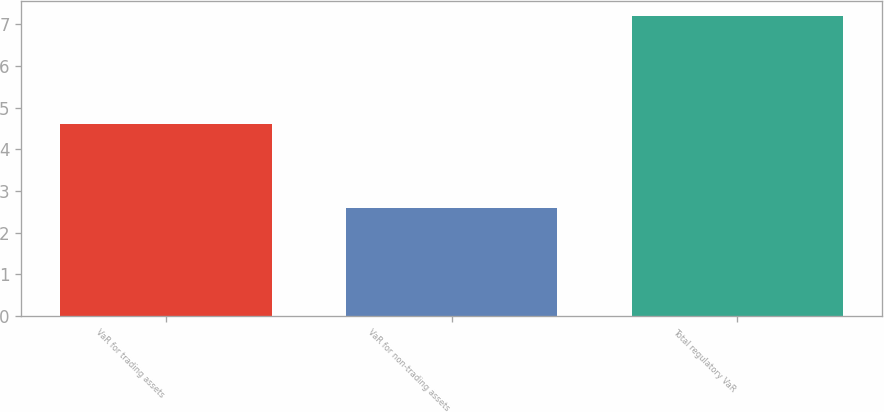Convert chart. <chart><loc_0><loc_0><loc_500><loc_500><bar_chart><fcel>VaR for trading assets<fcel>VaR for non-trading assets<fcel>Total regulatory VaR<nl><fcel>4.6<fcel>2.6<fcel>7.2<nl></chart> 